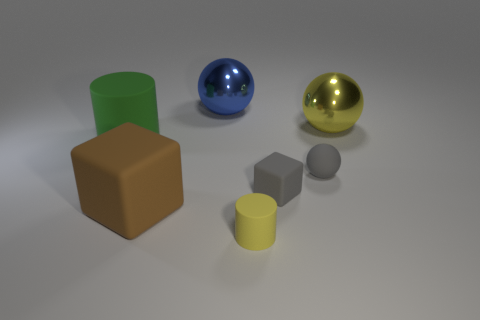Subtract all purple cubes. Subtract all gray balls. How many cubes are left? 2 Add 2 metal spheres. How many objects exist? 9 Subtract all spheres. How many objects are left? 4 Add 6 small gray blocks. How many small gray blocks are left? 7 Add 2 gray rubber things. How many gray rubber things exist? 4 Subtract 1 blue balls. How many objects are left? 6 Subtract all cylinders. Subtract all blue shiny things. How many objects are left? 4 